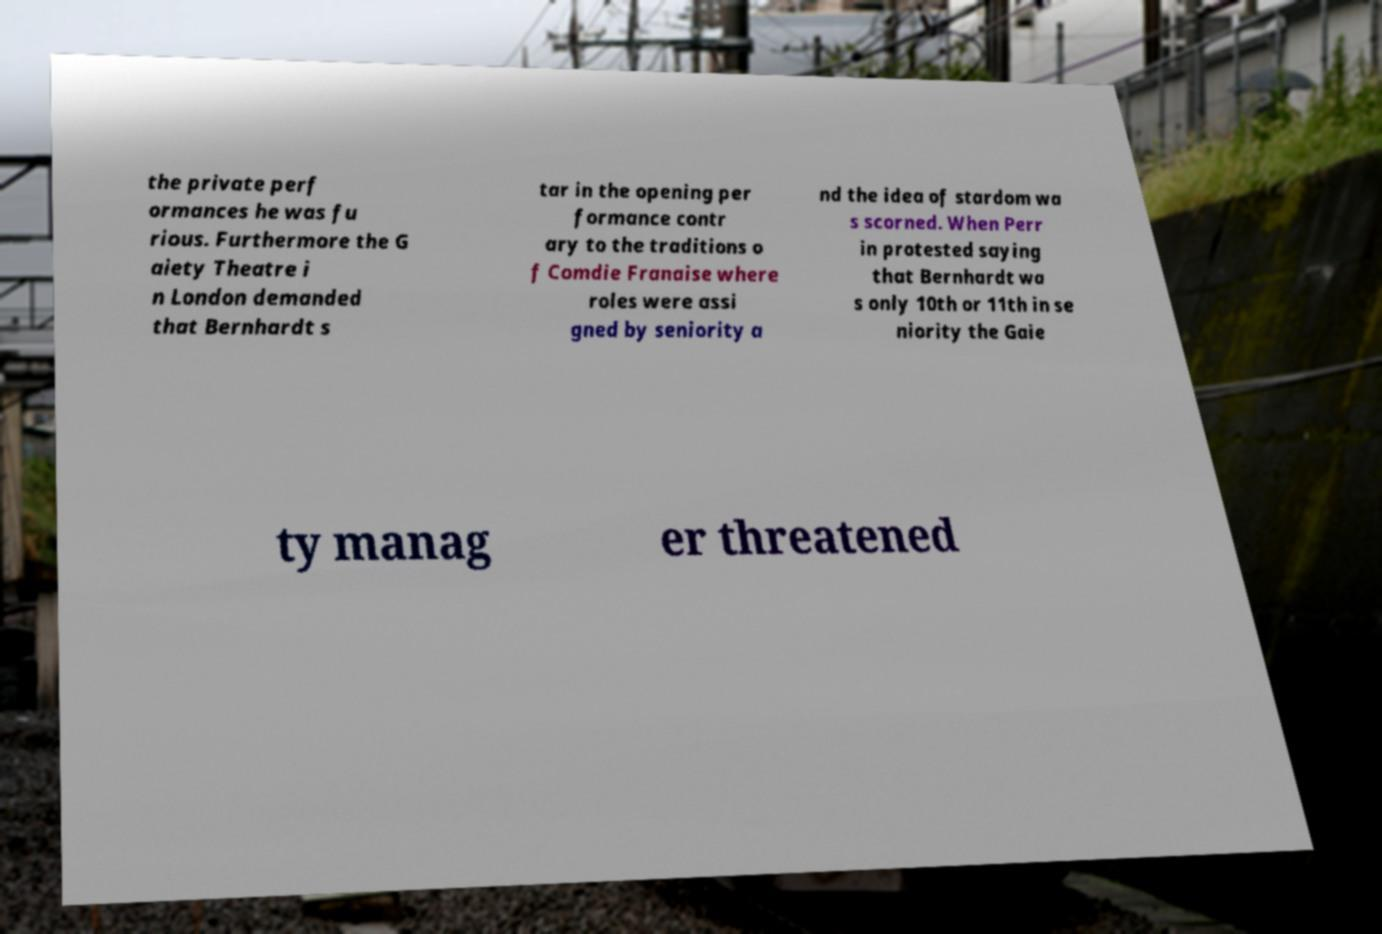Can you read and provide the text displayed in the image?This photo seems to have some interesting text. Can you extract and type it out for me? the private perf ormances he was fu rious. Furthermore the G aiety Theatre i n London demanded that Bernhardt s tar in the opening per formance contr ary to the traditions o f Comdie Franaise where roles were assi gned by seniority a nd the idea of stardom wa s scorned. When Perr in protested saying that Bernhardt wa s only 10th or 11th in se niority the Gaie ty manag er threatened 